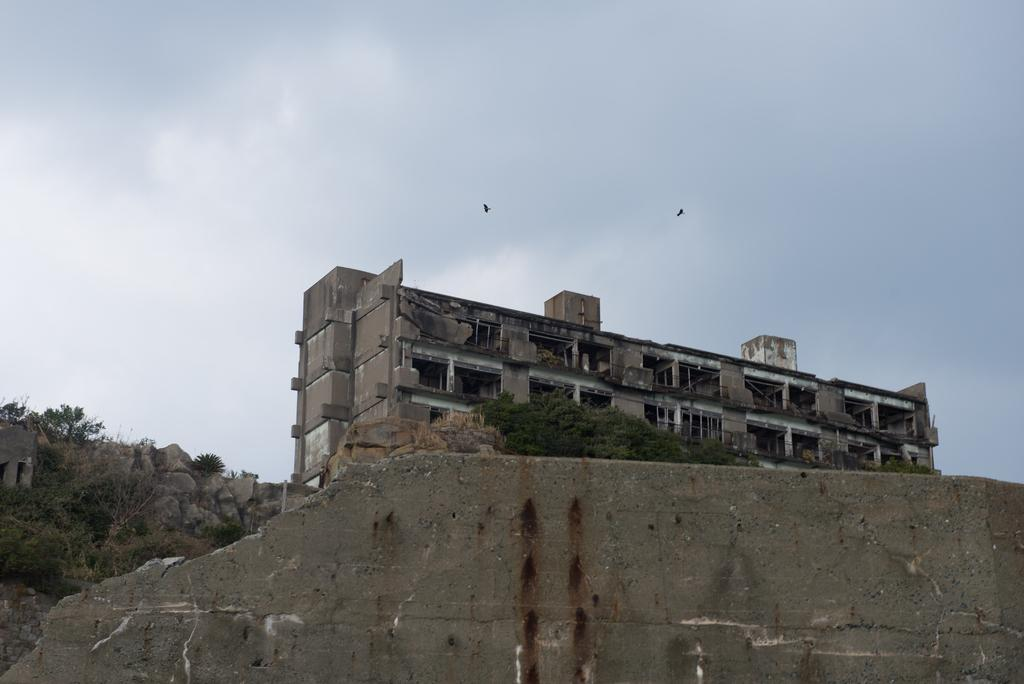What type of structure is present in the image? There is a building in the image. What other natural elements can be seen in the image? There are trees and rocks in the image. Are there any animals visible in the image? Yes, two birds are flying in the air. How would you describe the sky in the image? The sky is visible in the image and has a white and blue color. What is the position of the wall in the image? There is a wall in front of the image. How many babies are crawling on the wall in the image? There are no babies present in the image; it only features a building, trees, rocks, birds, and a wall. What day of the week is depicted in the image? The image does not depict a specific day of the week; it is a still image without any temporal context. 